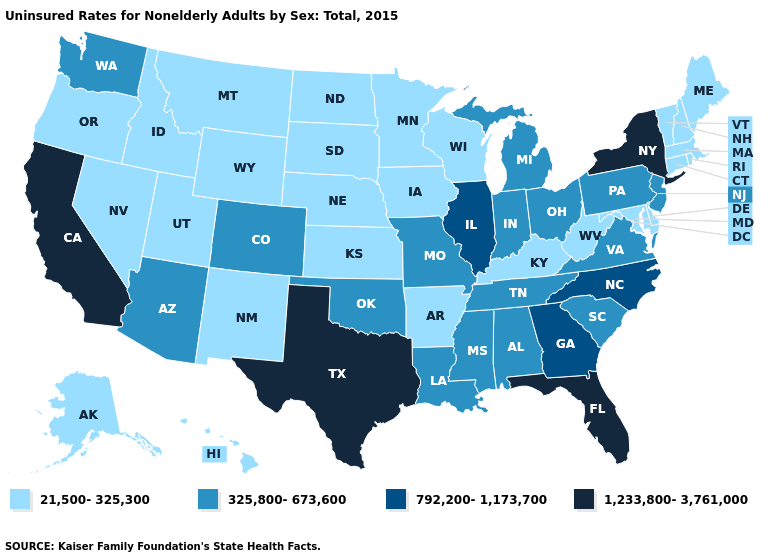Among the states that border Tennessee , does Arkansas have the highest value?
Quick response, please. No. Does Texas have the highest value in the USA?
Keep it brief. Yes. Name the states that have a value in the range 325,800-673,600?
Quick response, please. Alabama, Arizona, Colorado, Indiana, Louisiana, Michigan, Mississippi, Missouri, New Jersey, Ohio, Oklahoma, Pennsylvania, South Carolina, Tennessee, Virginia, Washington. Does the first symbol in the legend represent the smallest category?
Quick response, please. Yes. Which states have the highest value in the USA?
Keep it brief. California, Florida, New York, Texas. What is the value of Kentucky?
Concise answer only. 21,500-325,300. What is the value of Maine?
Concise answer only. 21,500-325,300. What is the value of Montana?
Answer briefly. 21,500-325,300. Does Georgia have the lowest value in the USA?
Keep it brief. No. Does the map have missing data?
Concise answer only. No. What is the value of New Jersey?
Write a very short answer. 325,800-673,600. Among the states that border Vermont , which have the highest value?
Short answer required. New York. What is the value of Washington?
Be succinct. 325,800-673,600. Is the legend a continuous bar?
Be succinct. No. What is the highest value in the USA?
Answer briefly. 1,233,800-3,761,000. 